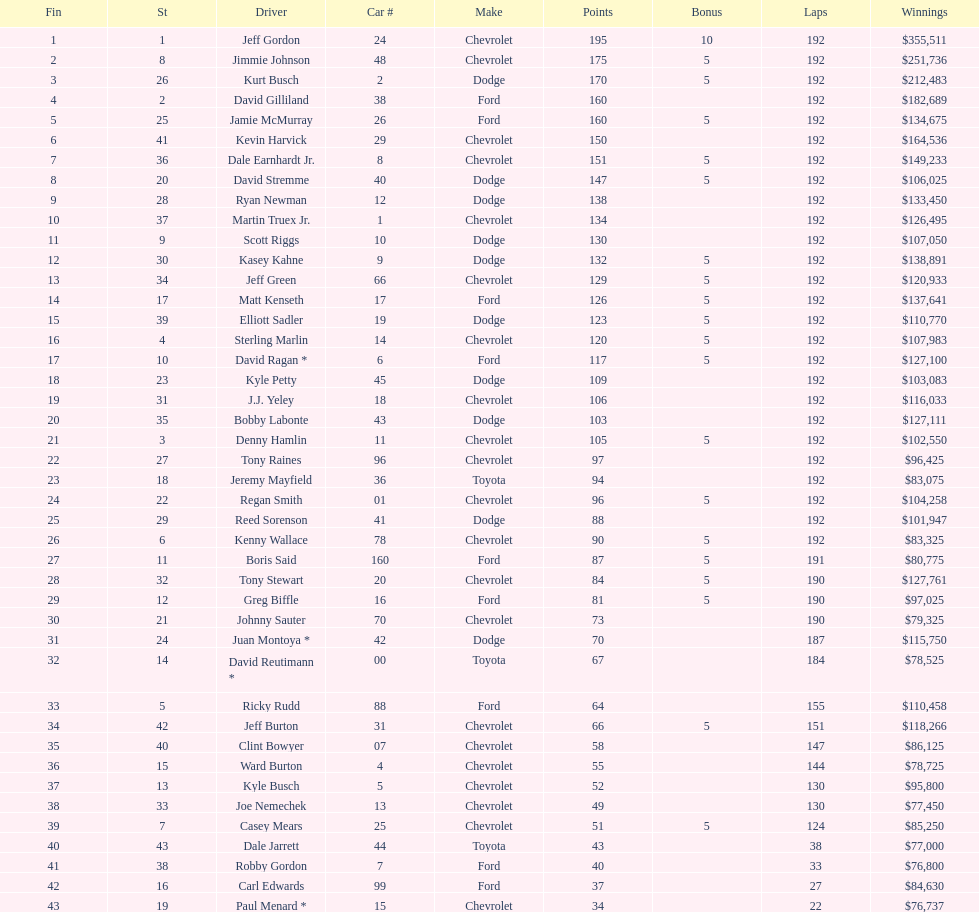How many drivers earned no bonus for this race? 23. 